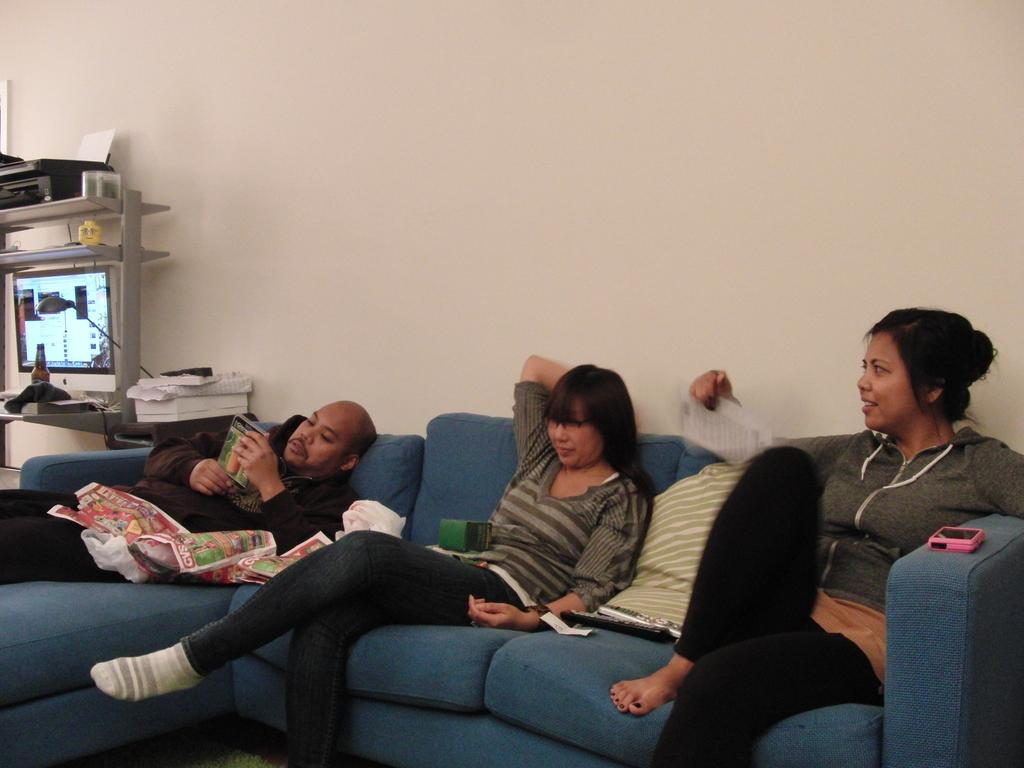How many people are present in the image? There are three people in the image. What are two of the people doing in the image? Two of the people are sitting on a sofa. What is the third person doing in the image? One person is lying on the sofa. What can be seen in the background of the image? There is a screen and a bottle in the background of the image. What type of adjustment does the sofa need in the image? There is no indication in the image that the sofa needs any adjustment. Can you tell me who the partner of the person lying on the sofa is? There is no information about partners or relationships in the image. 